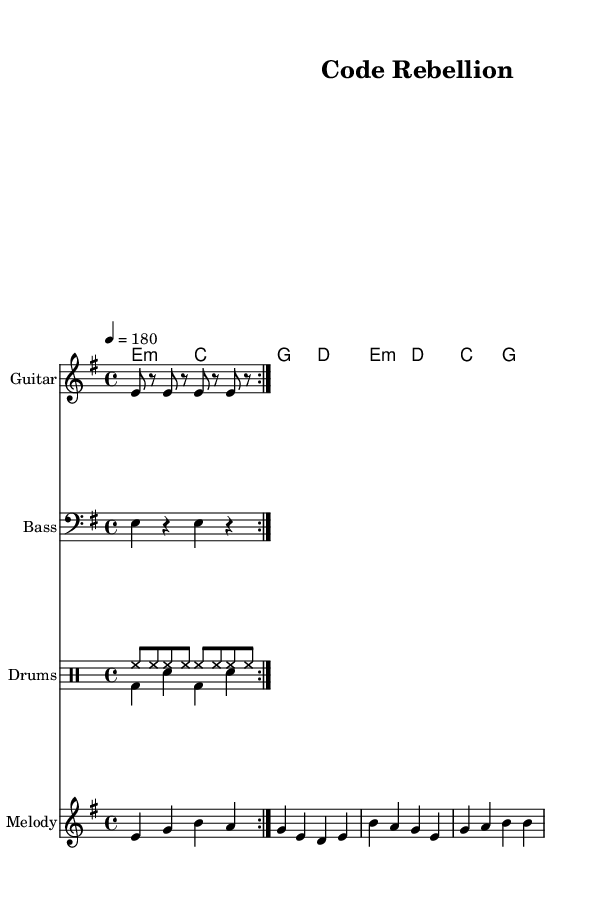What is the key signature of this music? The key signature is indicated at the beginning of the piece. There is one sharp, which is characteristic of the E minor scale.
Answer: E minor What is the time signature of this music? The time signature is found at the start of the score, where it shows a "4/4" indication. This means there are four beats per measure.
Answer: 4/4 What is the tempo marking for this piece? The tempo marking is indicated at the start of the score. It states "4 = 180," meaning there should be 180 quarter note beats per minute.
Answer: 180 How many measures are there in the verse section? The verse section is represented by the musical notation within the stanza indicated. There are a total of four measures in the verse section.
Answer: 4 What is the primary theme of the lyrics? The lyrics discuss themes related to corporate monopolies and the critique of patent laws. The focus is on rebellion against corporate control over knowledge and code.
Answer: Code rebellion Which instrument plays the melody in this piece? The melody is specified within the score. It is assigned to the staff labeled "Melody," suggesting that the designated instrument for this part is a lead instrument, typically a guitar or keyboard.
Answer: Melody What is the repeated musical section indicated in the score? The score has a repeated segment suggested by the "volta" markings in both the guitar and bass riffs, indicating that those parts are intended to be played twice before moving on.
Answer: Volta 